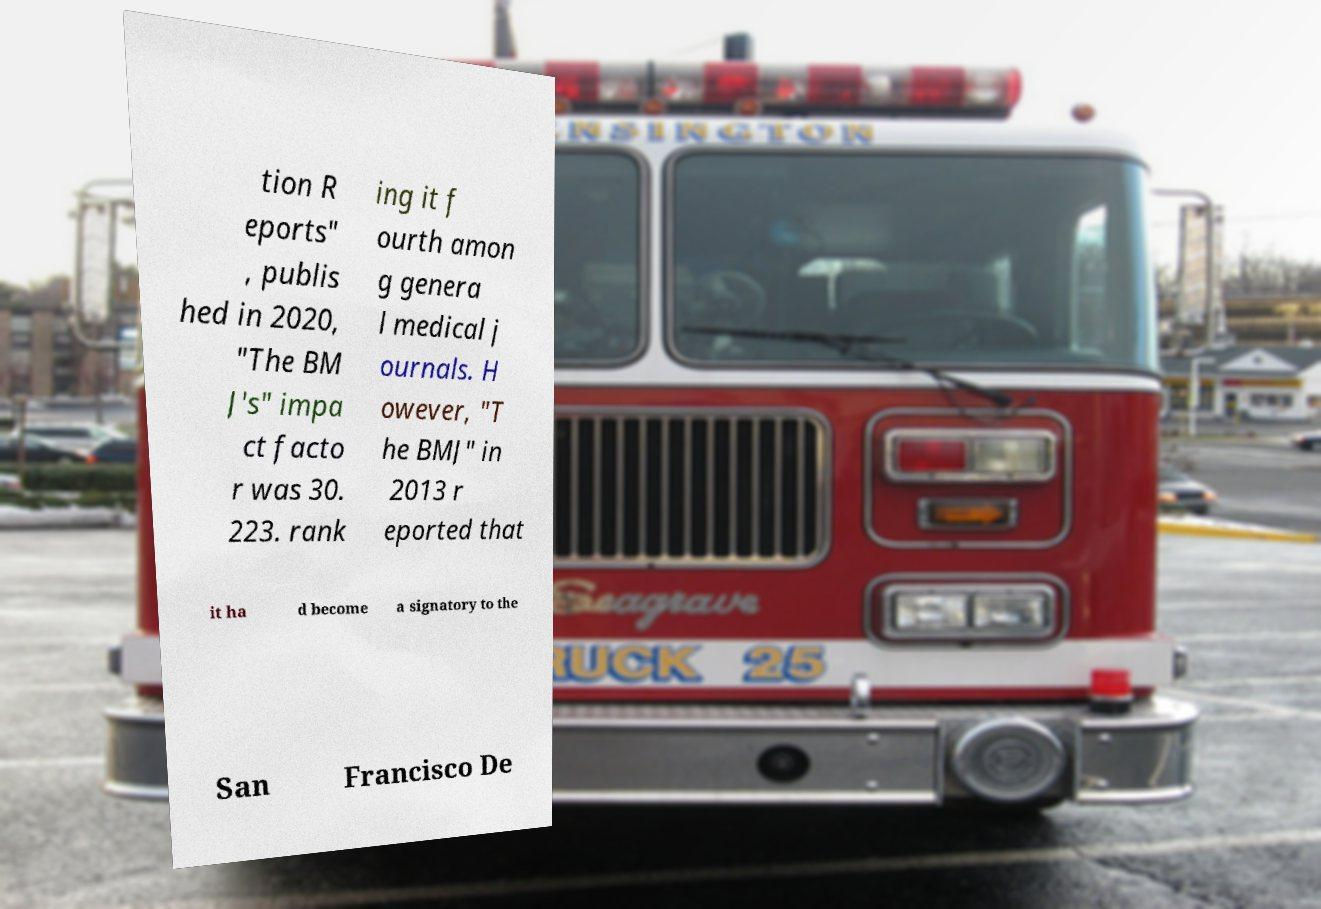Can you accurately transcribe the text from the provided image for me? tion R eports" , publis hed in 2020, "The BM J's" impa ct facto r was 30. 223. rank ing it f ourth amon g genera l medical j ournals. H owever, "T he BMJ" in 2013 r eported that it ha d become a signatory to the San Francisco De 